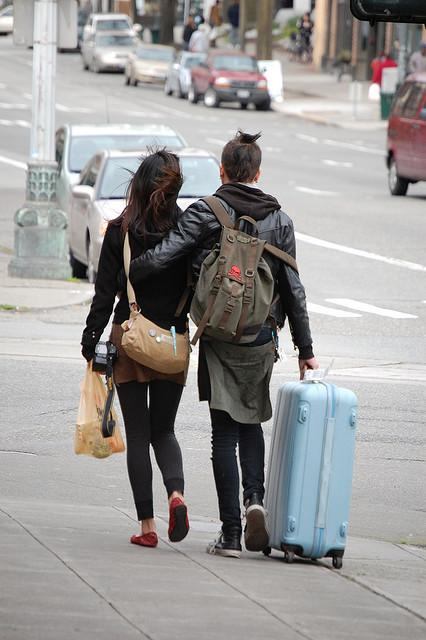What type of parking is available?

Choices:
A) valet
B) diagonal
C) lot
D) street street 